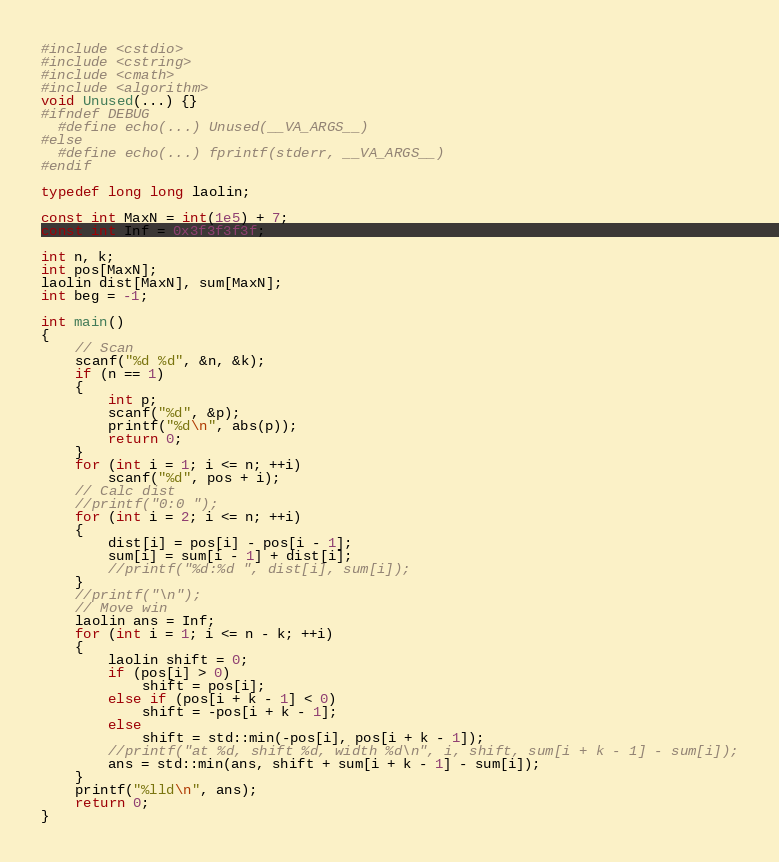Convert code to text. <code><loc_0><loc_0><loc_500><loc_500><_C++_>#include <cstdio>
#include <cstring>
#include <cmath>
#include <algorithm>
void Unused(...) {}
#ifndef DEBUG
  #define echo(...) Unused(__VA_ARGS__)
#else
  #define echo(...) fprintf(stderr, __VA_ARGS__)
#endif

typedef long long laolin;

const int MaxN = int(1e5) + 7;
const int Inf = 0x3f3f3f3f;

int n, k;
int pos[MaxN];
laolin dist[MaxN], sum[MaxN];
int beg = -1;

int main()
{
    // Scan
    scanf("%d %d", &n, &k);
    if (n == 1)
    {
        int p;
        scanf("%d", &p);
        printf("%d\n", abs(p));
        return 0;
    }
    for (int i = 1; i <= n; ++i)
        scanf("%d", pos + i);
    // Calc dist
    //printf("0:0 ");
    for (int i = 2; i <= n; ++i)
    {
        dist[i] = pos[i] - pos[i - 1];
        sum[i] = sum[i - 1] + dist[i];
        //printf("%d:%d ", dist[i], sum[i]);
    }
    //printf("\n");
    // Move win
    laolin ans = Inf;
    for (int i = 1; i <= n - k; ++i)
    {
        laolin shift = 0;
        if (pos[i] > 0)
            shift = pos[i];
        else if (pos[i + k - 1] < 0)
            shift = -pos[i + k - 1];
        else
            shift = std::min(-pos[i], pos[i + k - 1]);
        //printf("at %d, shift %d, width %d\n", i, shift, sum[i + k - 1] - sum[i]);
        ans = std::min(ans, shift + sum[i + k - 1] - sum[i]);
    }
    printf("%lld\n", ans);
    return 0;
}

</code> 